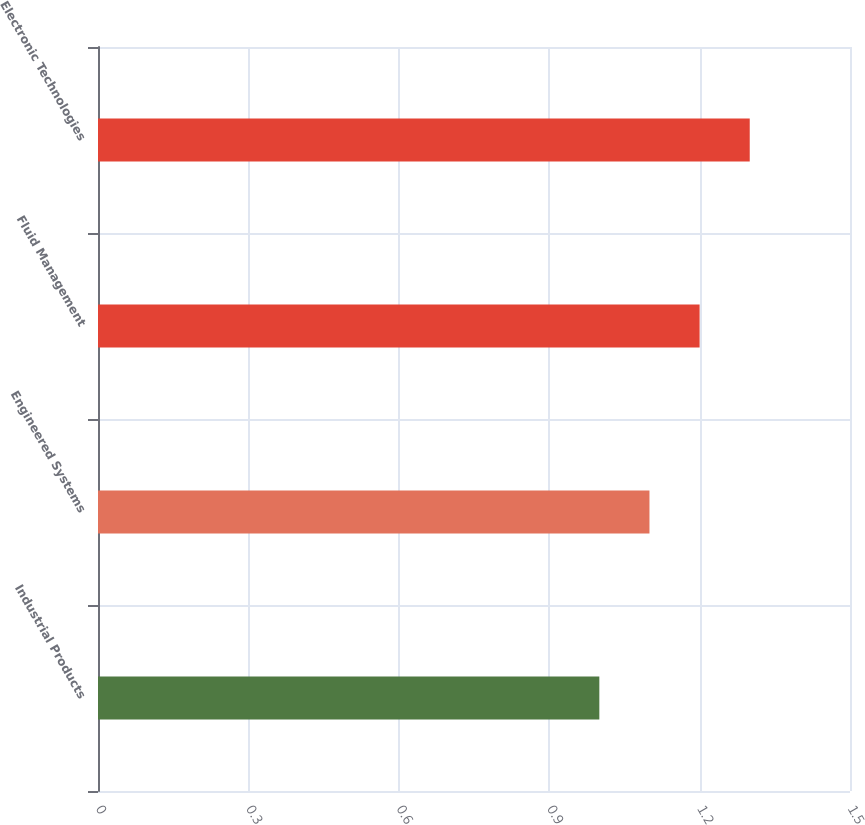<chart> <loc_0><loc_0><loc_500><loc_500><bar_chart><fcel>Industrial Products<fcel>Engineered Systems<fcel>Fluid Management<fcel>Electronic Technologies<nl><fcel>1<fcel>1.1<fcel>1.2<fcel>1.3<nl></chart> 